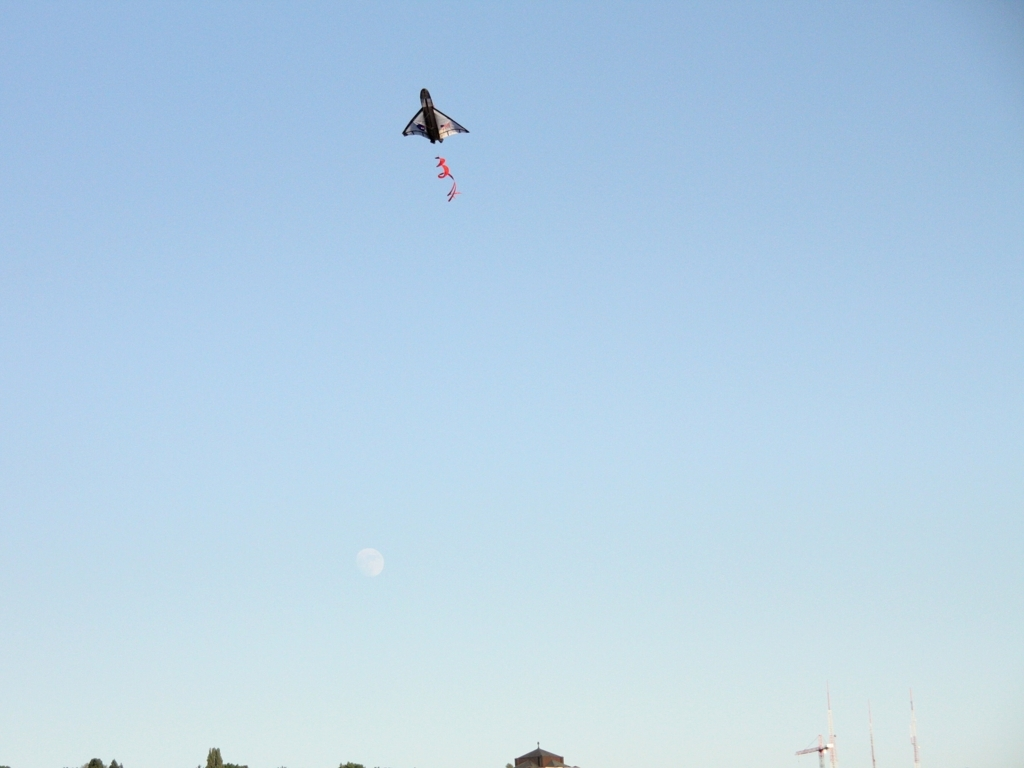Are there any sharpness issues in the image? Upon review, the image appears to be reasonably sharp, with clear details visible in the flight object and the background. The edges around the flying object are well-defined against the sky, and the trailing element has distinguishable twists, affirming good focus in the frame. No significant sharpness issues detract from the overall quality of the photograph. 